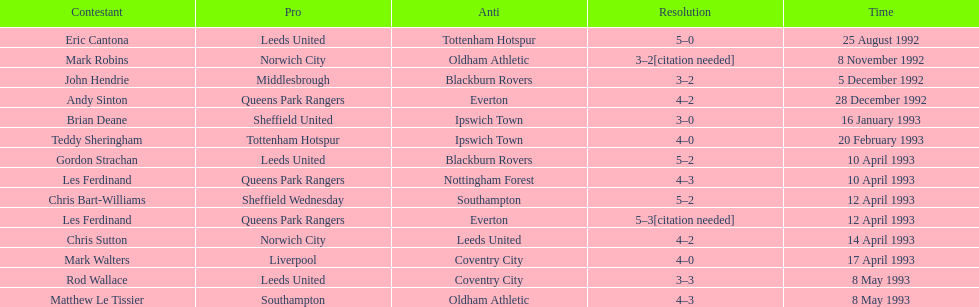Southampton played on may 8th, 1993, who was their opponent? Oldham Athletic. 